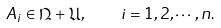<formula> <loc_0><loc_0><loc_500><loc_500>A _ { i } \in \mathfrak { N } + \mathfrak { U } , \quad i = 1 , 2 , \cdots , n .</formula> 